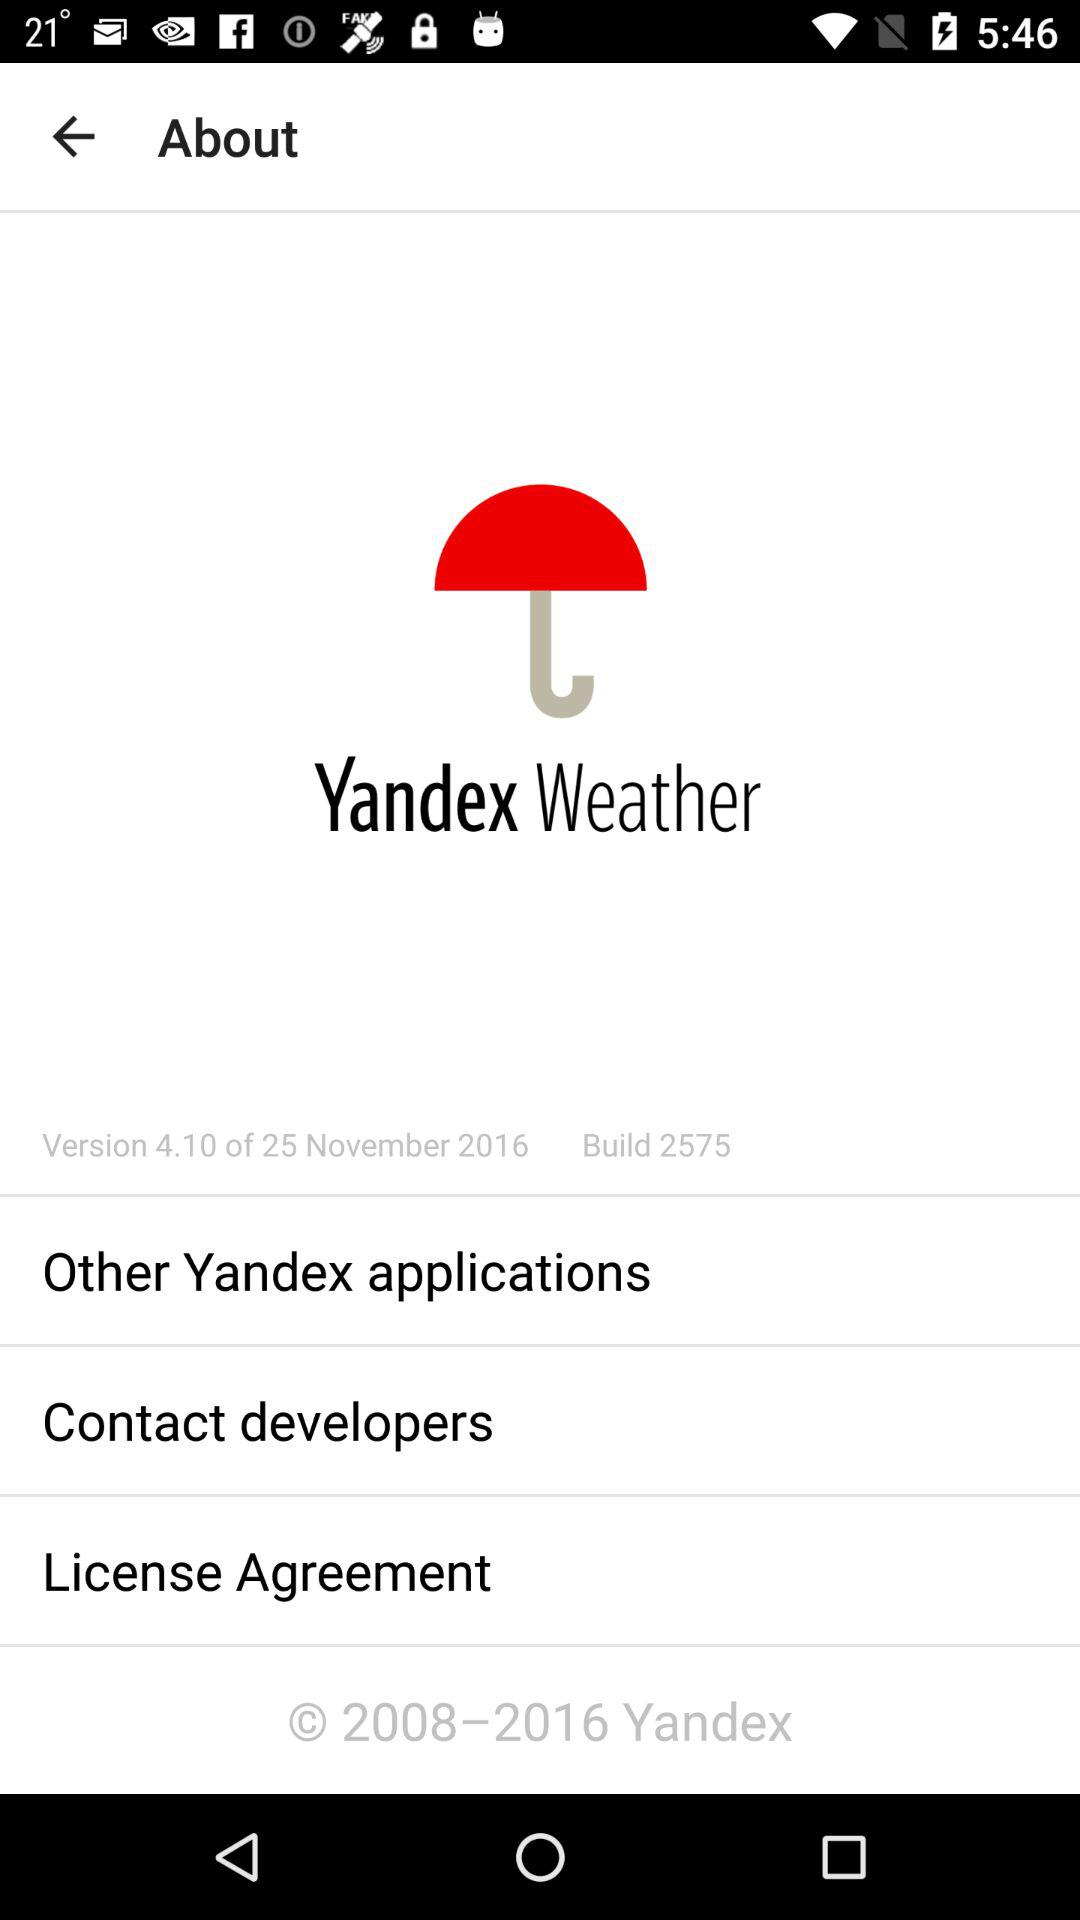What is the build number? The build number is 2575. 